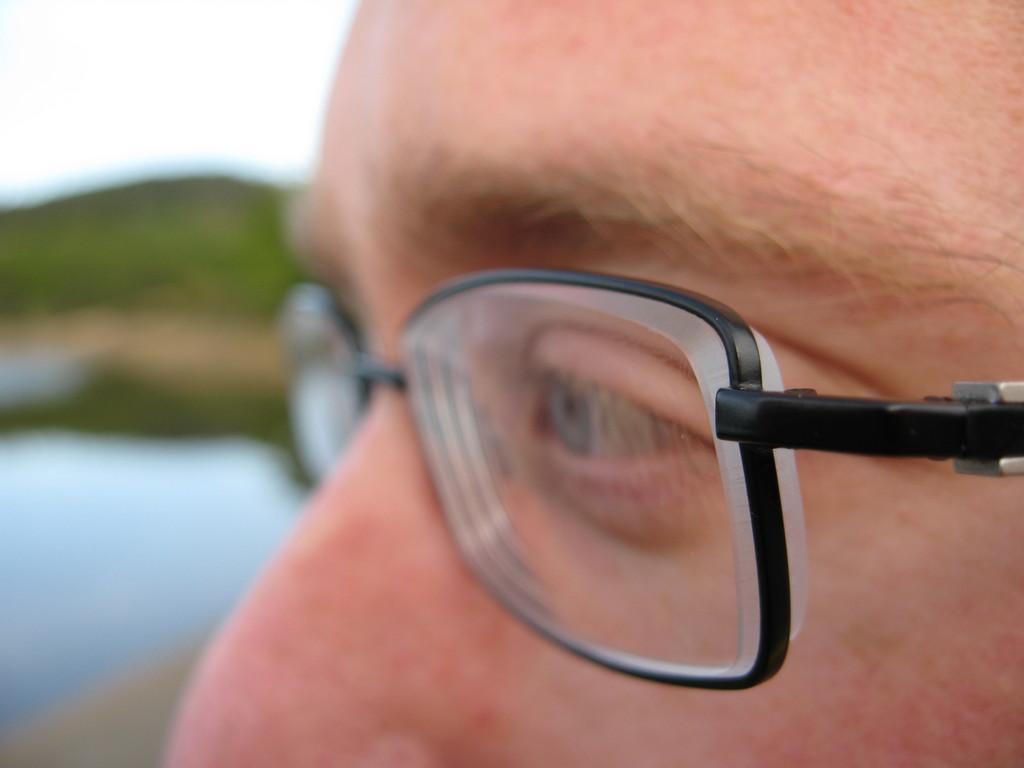How would you summarize this image in a sentence or two? In this picture I can see a person wearing spectacles. 